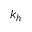Convert formula to latex. <formula><loc_0><loc_0><loc_500><loc_500>k _ { h }</formula> 